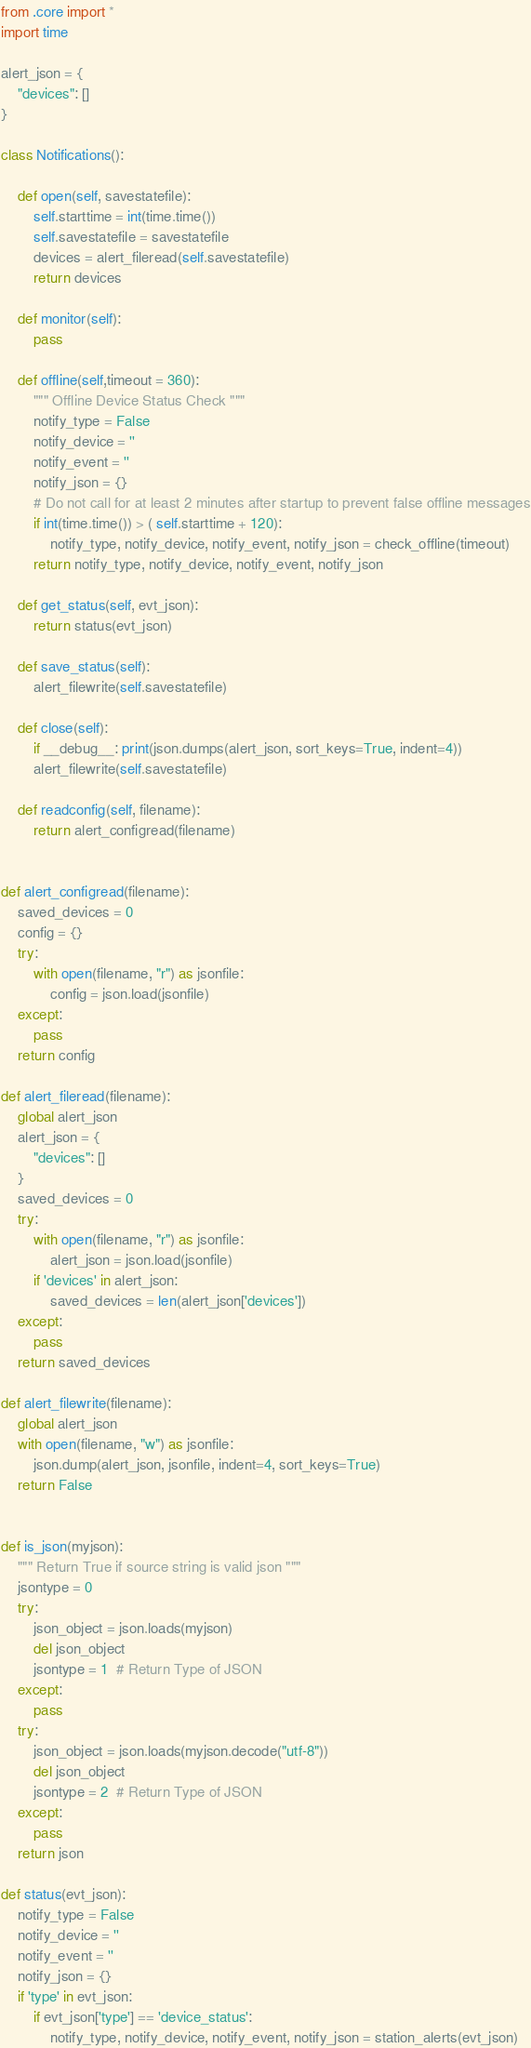<code> <loc_0><loc_0><loc_500><loc_500><_Python_>from .core import *
import time

alert_json = {
    "devices": []
}

class Notifications():

    def open(self, savestatefile):
        self.starttime = int(time.time())
        self.savestatefile = savestatefile
        devices = alert_fileread(self.savestatefile)
        return devices

    def monitor(self):
        pass

    def offline(self,timeout = 360):
        """ Offline Device Status Check """
        notify_type = False
        notify_device = ''
        notify_event = ''
        notify_json = {}
        # Do not call for at least 2 minutes after startup to prevent false offline messages
        if int(time.time()) > ( self.starttime + 120):
            notify_type, notify_device, notify_event, notify_json = check_offline(timeout)
        return notify_type, notify_device, notify_event, notify_json

    def get_status(self, evt_json):
        return status(evt_json)

    def save_status(self):
        alert_filewrite(self.savestatefile)

    def close(self):
        if __debug__: print(json.dumps(alert_json, sort_keys=True, indent=4))
        alert_filewrite(self.savestatefile)

    def readconfig(self, filename):
        return alert_configread(filename)


def alert_configread(filename):
    saved_devices = 0
    config = {}
    try:
        with open(filename, "r") as jsonfile:
            config = json.load(jsonfile)
    except:
        pass
    return config

def alert_fileread(filename):
    global alert_json
    alert_json = {
        "devices": []
    }
    saved_devices = 0
    try:
        with open(filename, "r") as jsonfile:
            alert_json = json.load(jsonfile)
        if 'devices' in alert_json:
            saved_devices = len(alert_json['devices'])
    except:
        pass
    return saved_devices

def alert_filewrite(filename):
    global alert_json
    with open(filename, "w") as jsonfile:
        json.dump(alert_json, jsonfile, indent=4, sort_keys=True)
    return False


def is_json(myjson):
    """ Return True if source string is valid json """
    jsontype = 0
    try:
        json_object = json.loads(myjson)
        del json_object
        jsontype = 1  # Return Type of JSON
    except:
        pass
    try:
        json_object = json.loads(myjson.decode("utf-8"))
        del json_object
        jsontype = 2  # Return Type of JSON
    except:
        pass
    return json

def status(evt_json):
    notify_type = False
    notify_device = ''
    notify_event = ''
    notify_json = {}
    if 'type' in evt_json:
        if evt_json['type'] == 'device_status':
            notify_type, notify_device, notify_event, notify_json = station_alerts(evt_json)</code> 